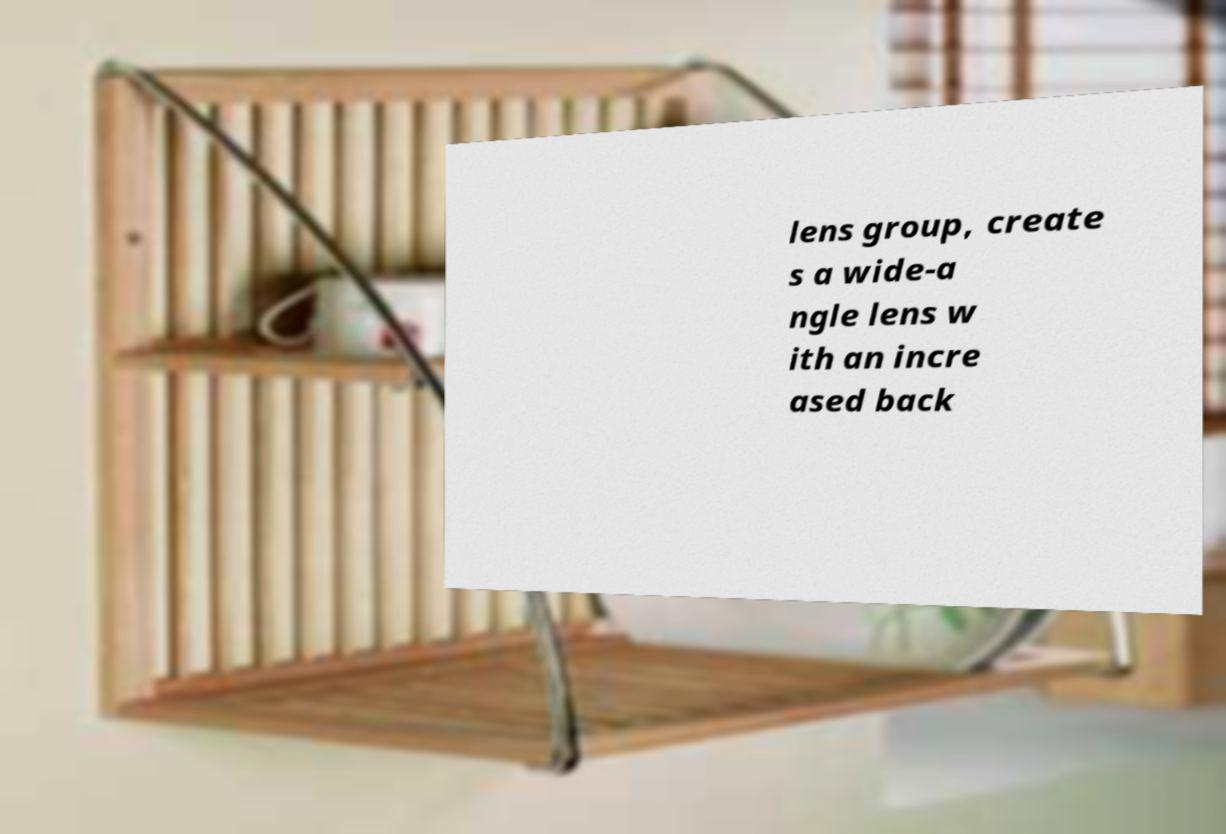I need the written content from this picture converted into text. Can you do that? lens group, create s a wide-a ngle lens w ith an incre ased back 